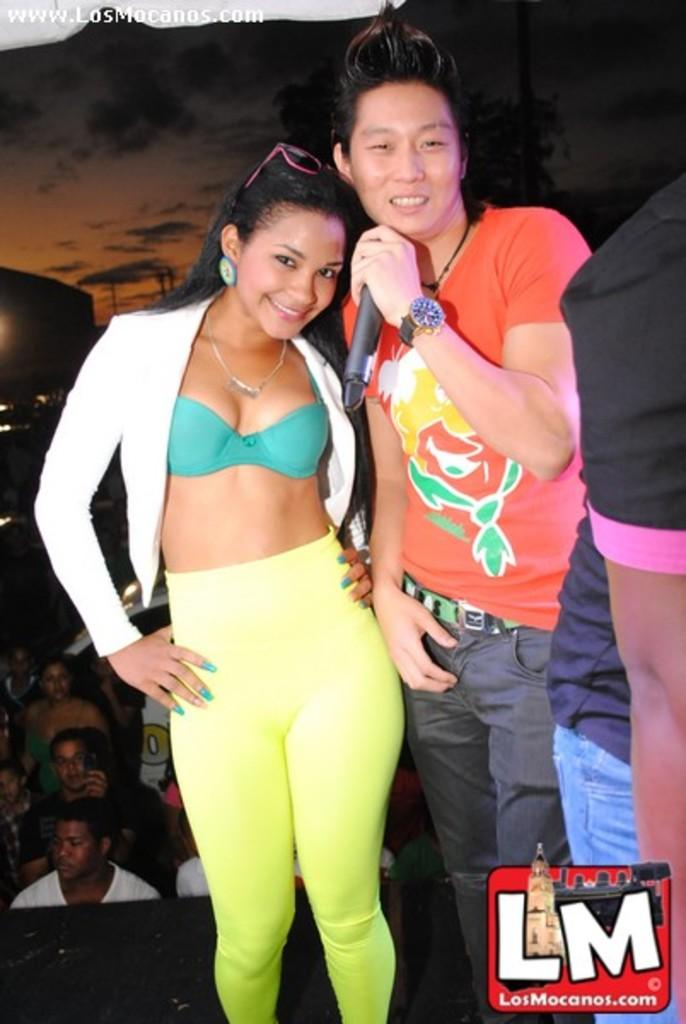What is the composition of the group in the image? There is a group of people in the image. Can you identify any specific individuals in the group? Yes, there is a man and a woman in the middle of the image. What is the woman doing in the image? The woman is smiling. What object is the man holding in the image? The man is holding a microphone. What type of lipstick is the woman wearing in the image? There is no lipstick visible in the image, and the woman's lips are not mentioned in the provided facts. What holiday is being celebrated in the image? There is no indication of a holiday being celebrated in the image. 